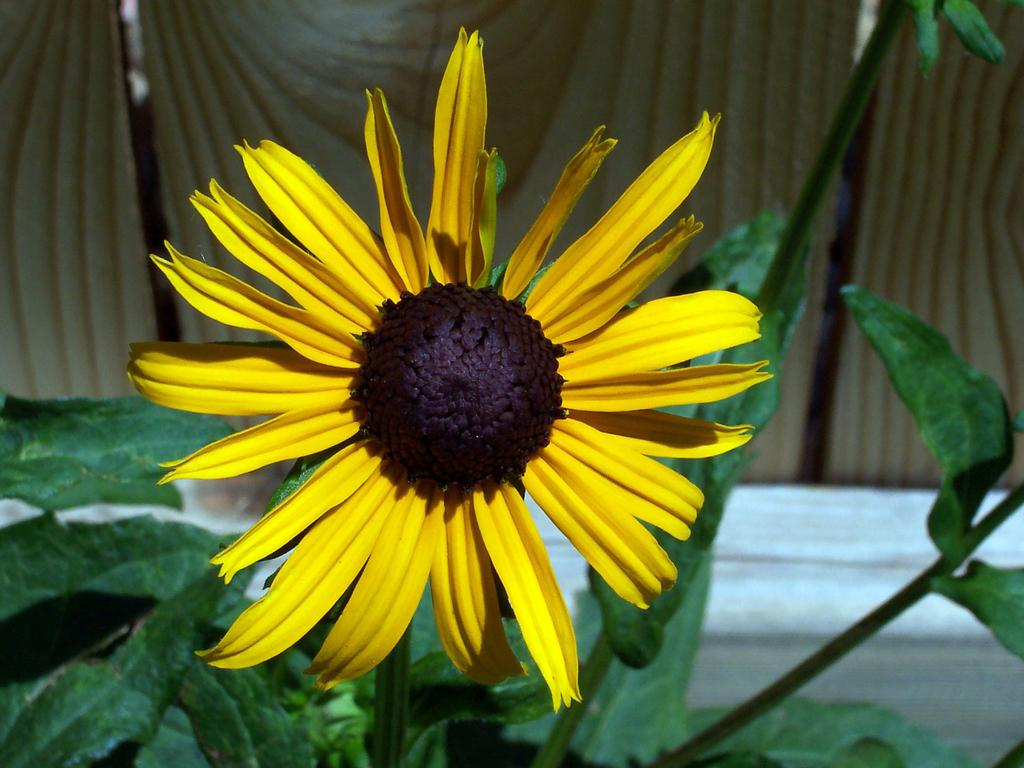What is the main subject of the image? There is a flower in the center of the image. What can be seen in the background area? There are leaves and wooden boards in the background area. What type of calculator is visible in the image? There is no calculator present in the image. How much has the flower grown since it was first planted? The image does not provide information about the flower's growth since it was first planted. 